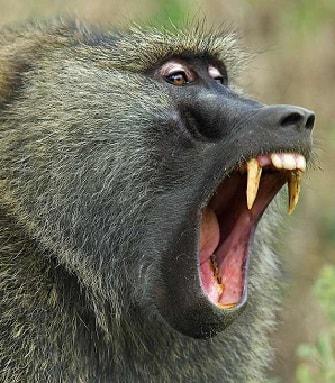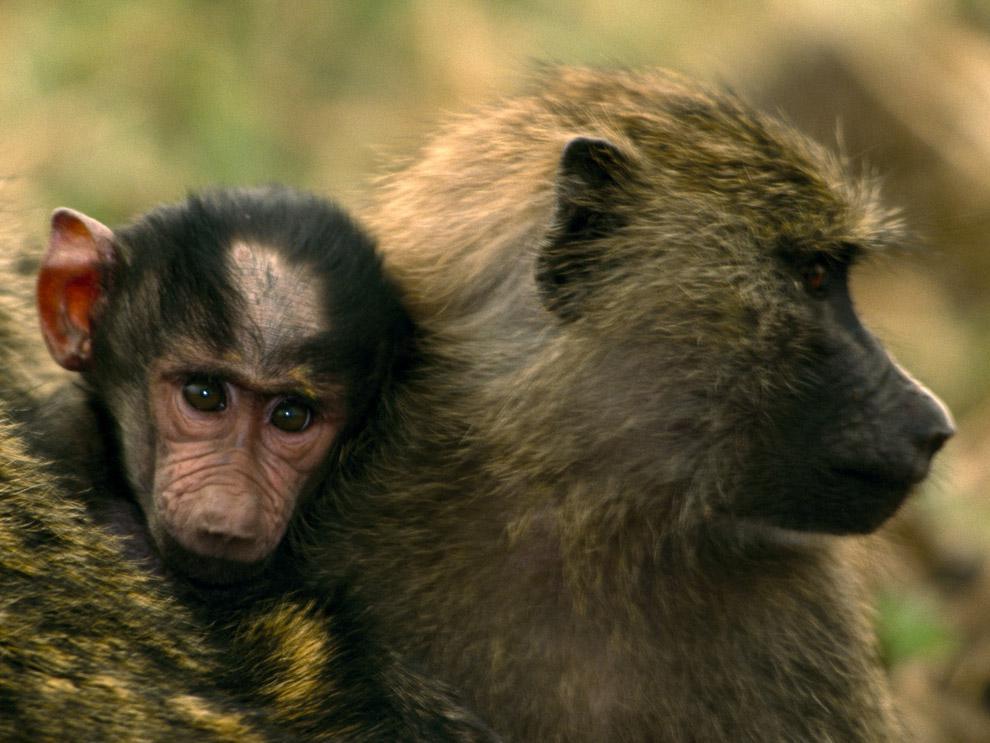The first image is the image on the left, the second image is the image on the right. Assess this claim about the two images: "A baby monkey is with an adult monkey.". Correct or not? Answer yes or no. Yes. 